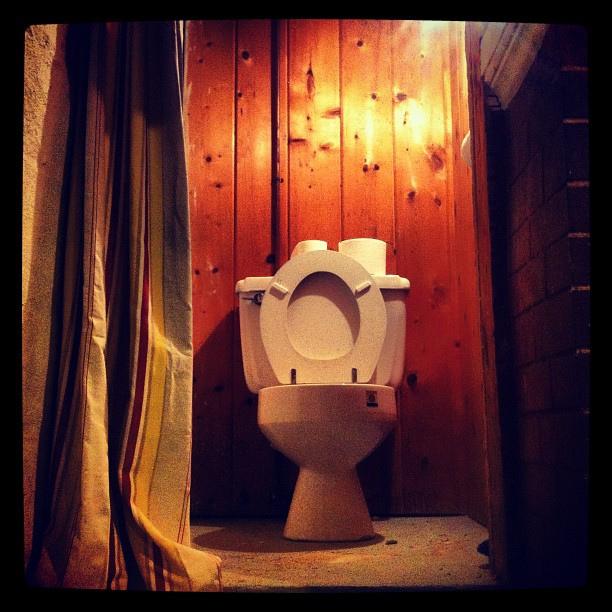Is there a curtain in the picture?
Give a very brief answer. Yes. Is there a fire in the room?
Short answer required. No. Is the toilet seat down?
Answer briefly. No. 